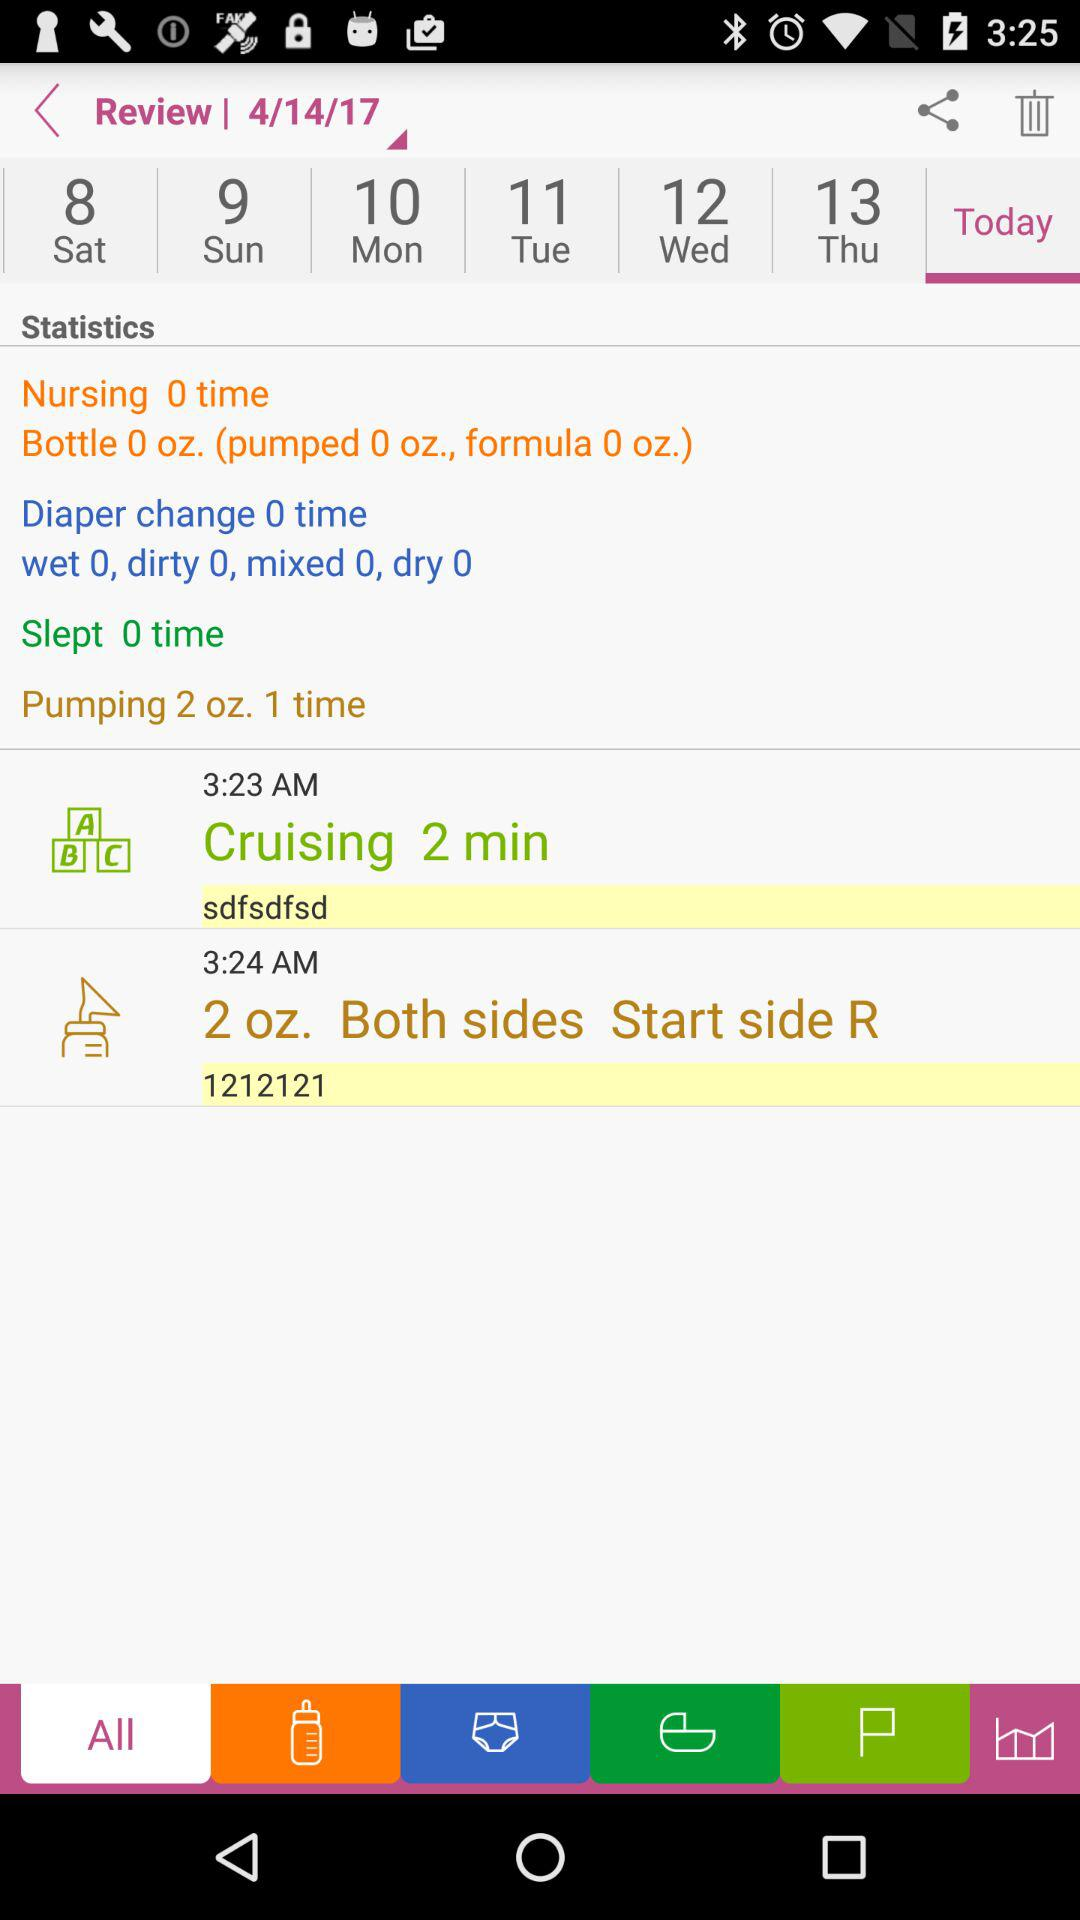How many more times has the baby been pumped than diaper changed?
Answer the question using a single word or phrase. 1 